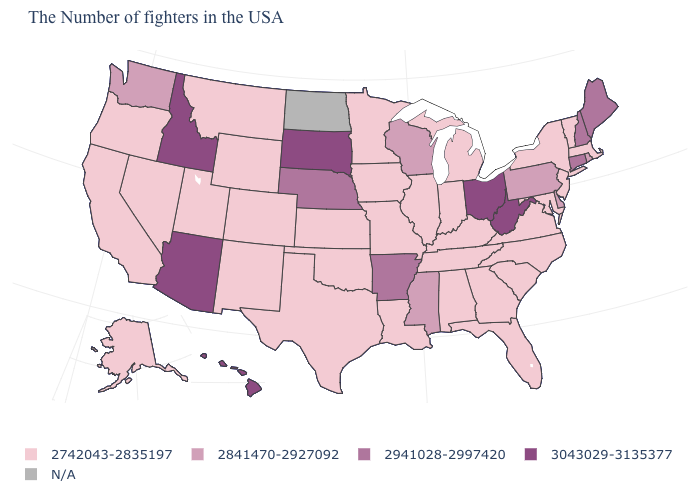What is the highest value in the West ?
Keep it brief. 3043029-3135377. Name the states that have a value in the range 2841470-2927092?
Answer briefly. Rhode Island, Delaware, Pennsylvania, Wisconsin, Mississippi, Washington. What is the value of South Carolina?
Keep it brief. 2742043-2835197. What is the lowest value in the USA?
Write a very short answer. 2742043-2835197. Does the map have missing data?
Be succinct. Yes. Which states have the lowest value in the South?
Write a very short answer. Maryland, Virginia, North Carolina, South Carolina, Florida, Georgia, Kentucky, Alabama, Tennessee, Louisiana, Oklahoma, Texas. Does Georgia have the highest value in the USA?
Keep it brief. No. Does West Virginia have the lowest value in the USA?
Keep it brief. No. Which states hav the highest value in the MidWest?
Be succinct. Ohio, South Dakota. Among the states that border Massachusetts , does New Hampshire have the highest value?
Give a very brief answer. Yes. Does the map have missing data?
Give a very brief answer. Yes. What is the lowest value in states that border Rhode Island?
Short answer required. 2742043-2835197. What is the highest value in the Northeast ?
Quick response, please. 2941028-2997420. Which states hav the highest value in the MidWest?
Keep it brief. Ohio, South Dakota. Does Arizona have the highest value in the USA?
Keep it brief. Yes. 